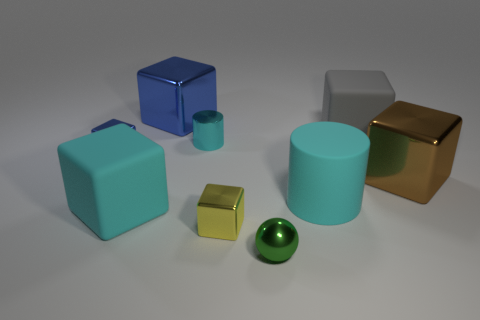Add 1 tiny metallic things. How many objects exist? 10 Subtract all big cyan matte blocks. How many blocks are left? 5 Subtract all cyan cylinders. How many blue cubes are left? 2 Subtract all blue cubes. How many cubes are left? 4 Subtract all spheres. How many objects are left? 8 Subtract all blue blocks. Subtract all purple balls. How many blocks are left? 4 Add 1 rubber blocks. How many rubber blocks exist? 3 Subtract 0 green cylinders. How many objects are left? 9 Subtract all blue metal objects. Subtract all spheres. How many objects are left? 6 Add 4 green spheres. How many green spheres are left? 5 